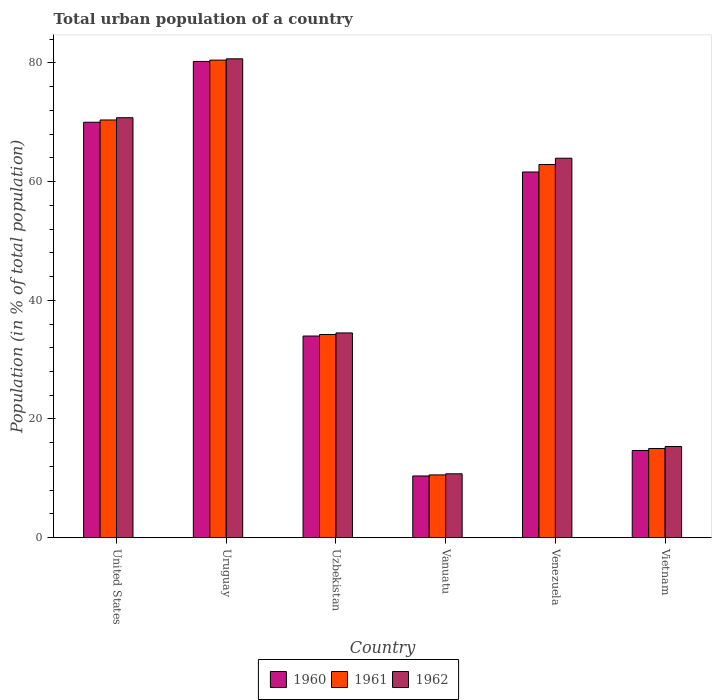How many bars are there on the 2nd tick from the left?
Give a very brief answer. 3. How many bars are there on the 2nd tick from the right?
Keep it short and to the point. 3. In how many cases, is the number of bars for a given country not equal to the number of legend labels?
Offer a very short reply. 0. What is the urban population in 1962 in United States?
Provide a short and direct response. 70.76. Across all countries, what is the maximum urban population in 1961?
Provide a succinct answer. 80.46. Across all countries, what is the minimum urban population in 1960?
Ensure brevity in your answer.  10.4. In which country was the urban population in 1962 maximum?
Your answer should be compact. Uruguay. In which country was the urban population in 1961 minimum?
Provide a succinct answer. Vanuatu. What is the total urban population in 1961 in the graph?
Your response must be concise. 273.57. What is the difference between the urban population in 1962 in United States and that in Venezuela?
Make the answer very short. 6.82. What is the difference between the urban population in 1960 in Vanuatu and the urban population in 1961 in Venezuela?
Provide a succinct answer. -52.47. What is the average urban population in 1960 per country?
Provide a short and direct response. 45.16. What is the difference between the urban population of/in 1960 and urban population of/in 1961 in Venezuela?
Your response must be concise. -1.26. In how many countries, is the urban population in 1961 greater than 36 %?
Ensure brevity in your answer.  3. What is the ratio of the urban population in 1961 in Vanuatu to that in Venezuela?
Your answer should be very brief. 0.17. Is the urban population in 1962 in United States less than that in Uzbekistan?
Ensure brevity in your answer.  No. Is the difference between the urban population in 1960 in Uzbekistan and Vanuatu greater than the difference between the urban population in 1961 in Uzbekistan and Vanuatu?
Offer a very short reply. No. What is the difference between the highest and the second highest urban population in 1961?
Keep it short and to the point. 17.59. What is the difference between the highest and the lowest urban population in 1962?
Your answer should be compact. 69.92. What does the 1st bar from the left in Venezuela represents?
Offer a very short reply. 1960. What does the 2nd bar from the right in Uruguay represents?
Offer a very short reply. 1961. Are the values on the major ticks of Y-axis written in scientific E-notation?
Provide a succinct answer. No. Does the graph contain any zero values?
Make the answer very short. No. How are the legend labels stacked?
Provide a short and direct response. Horizontal. What is the title of the graph?
Your answer should be compact. Total urban population of a country. What is the label or title of the Y-axis?
Your answer should be very brief. Population (in % of total population). What is the Population (in % of total population) in 1960 in United States?
Offer a terse response. 70. What is the Population (in % of total population) in 1961 in United States?
Offer a terse response. 70.38. What is the Population (in % of total population) of 1962 in United States?
Provide a succinct answer. 70.76. What is the Population (in % of total population) in 1960 in Uruguay?
Offer a very short reply. 80.24. What is the Population (in % of total population) in 1961 in Uruguay?
Provide a succinct answer. 80.46. What is the Population (in % of total population) of 1962 in Uruguay?
Your answer should be compact. 80.68. What is the Population (in % of total population) in 1960 in Uzbekistan?
Offer a terse response. 33.98. What is the Population (in % of total population) in 1961 in Uzbekistan?
Your answer should be compact. 34.24. What is the Population (in % of total population) of 1962 in Uzbekistan?
Give a very brief answer. 34.5. What is the Population (in % of total population) of 1960 in Vanuatu?
Ensure brevity in your answer.  10.4. What is the Population (in % of total population) in 1961 in Vanuatu?
Keep it short and to the point. 10.58. What is the Population (in % of total population) of 1962 in Vanuatu?
Keep it short and to the point. 10.77. What is the Population (in % of total population) of 1960 in Venezuela?
Your answer should be compact. 61.61. What is the Population (in % of total population) of 1961 in Venezuela?
Offer a terse response. 62.88. What is the Population (in % of total population) in 1962 in Venezuela?
Provide a succinct answer. 63.93. What is the Population (in % of total population) of 1960 in Vietnam?
Give a very brief answer. 14.7. What is the Population (in % of total population) of 1961 in Vietnam?
Keep it short and to the point. 15.03. What is the Population (in % of total population) in 1962 in Vietnam?
Your answer should be compact. 15.37. Across all countries, what is the maximum Population (in % of total population) of 1960?
Ensure brevity in your answer.  80.24. Across all countries, what is the maximum Population (in % of total population) in 1961?
Ensure brevity in your answer.  80.46. Across all countries, what is the maximum Population (in % of total population) in 1962?
Your answer should be compact. 80.68. Across all countries, what is the minimum Population (in % of total population) in 1960?
Provide a succinct answer. 10.4. Across all countries, what is the minimum Population (in % of total population) of 1961?
Keep it short and to the point. 10.58. Across all countries, what is the minimum Population (in % of total population) in 1962?
Offer a terse response. 10.77. What is the total Population (in % of total population) in 1960 in the graph?
Your answer should be compact. 270.93. What is the total Population (in % of total population) in 1961 in the graph?
Provide a succinct answer. 273.57. What is the total Population (in % of total population) of 1962 in the graph?
Give a very brief answer. 276. What is the difference between the Population (in % of total population) of 1960 in United States and that in Uruguay?
Provide a short and direct response. -10.24. What is the difference between the Population (in % of total population) of 1961 in United States and that in Uruguay?
Keep it short and to the point. -10.09. What is the difference between the Population (in % of total population) in 1962 in United States and that in Uruguay?
Ensure brevity in your answer.  -9.92. What is the difference between the Population (in % of total population) in 1960 in United States and that in Uzbekistan?
Make the answer very short. 36.02. What is the difference between the Population (in % of total population) in 1961 in United States and that in Uzbekistan?
Your answer should be very brief. 36.14. What is the difference between the Population (in % of total population) of 1962 in United States and that in Uzbekistan?
Offer a very short reply. 36.26. What is the difference between the Population (in % of total population) of 1960 in United States and that in Vanuatu?
Make the answer very short. 59.59. What is the difference between the Population (in % of total population) in 1961 in United States and that in Vanuatu?
Offer a terse response. 59.79. What is the difference between the Population (in % of total population) in 1962 in United States and that in Vanuatu?
Ensure brevity in your answer.  59.99. What is the difference between the Population (in % of total population) of 1960 in United States and that in Venezuela?
Provide a succinct answer. 8.38. What is the difference between the Population (in % of total population) in 1961 in United States and that in Venezuela?
Make the answer very short. 7.5. What is the difference between the Population (in % of total population) of 1962 in United States and that in Venezuela?
Your response must be concise. 6.82. What is the difference between the Population (in % of total population) in 1960 in United States and that in Vietnam?
Your answer should be compact. 55.3. What is the difference between the Population (in % of total population) of 1961 in United States and that in Vietnam?
Make the answer very short. 55.35. What is the difference between the Population (in % of total population) in 1962 in United States and that in Vietnam?
Make the answer very short. 55.39. What is the difference between the Population (in % of total population) of 1960 in Uruguay and that in Uzbekistan?
Offer a very short reply. 46.26. What is the difference between the Population (in % of total population) in 1961 in Uruguay and that in Uzbekistan?
Your response must be concise. 46.22. What is the difference between the Population (in % of total population) of 1962 in Uruguay and that in Uzbekistan?
Make the answer very short. 46.18. What is the difference between the Population (in % of total population) of 1960 in Uruguay and that in Vanuatu?
Provide a short and direct response. 69.84. What is the difference between the Population (in % of total population) in 1961 in Uruguay and that in Vanuatu?
Offer a terse response. 69.88. What is the difference between the Population (in % of total population) of 1962 in Uruguay and that in Vanuatu?
Make the answer very short. 69.92. What is the difference between the Population (in % of total population) in 1960 in Uruguay and that in Venezuela?
Your answer should be very brief. 18.63. What is the difference between the Population (in % of total population) of 1961 in Uruguay and that in Venezuela?
Offer a terse response. 17.59. What is the difference between the Population (in % of total population) of 1962 in Uruguay and that in Venezuela?
Provide a succinct answer. 16.75. What is the difference between the Population (in % of total population) of 1960 in Uruguay and that in Vietnam?
Your response must be concise. 65.54. What is the difference between the Population (in % of total population) in 1961 in Uruguay and that in Vietnam?
Ensure brevity in your answer.  65.43. What is the difference between the Population (in % of total population) of 1962 in Uruguay and that in Vietnam?
Your answer should be very brief. 65.31. What is the difference between the Population (in % of total population) in 1960 in Uzbekistan and that in Vanuatu?
Offer a very short reply. 23.57. What is the difference between the Population (in % of total population) in 1961 in Uzbekistan and that in Vanuatu?
Your answer should be very brief. 23.66. What is the difference between the Population (in % of total population) of 1962 in Uzbekistan and that in Vanuatu?
Ensure brevity in your answer.  23.73. What is the difference between the Population (in % of total population) of 1960 in Uzbekistan and that in Venezuela?
Your response must be concise. -27.64. What is the difference between the Population (in % of total population) in 1961 in Uzbekistan and that in Venezuela?
Offer a very short reply. -28.64. What is the difference between the Population (in % of total population) of 1962 in Uzbekistan and that in Venezuela?
Your answer should be compact. -29.43. What is the difference between the Population (in % of total population) in 1960 in Uzbekistan and that in Vietnam?
Offer a terse response. 19.28. What is the difference between the Population (in % of total population) of 1961 in Uzbekistan and that in Vietnam?
Provide a short and direct response. 19.21. What is the difference between the Population (in % of total population) in 1962 in Uzbekistan and that in Vietnam?
Give a very brief answer. 19.13. What is the difference between the Population (in % of total population) in 1960 in Vanuatu and that in Venezuela?
Provide a succinct answer. -51.21. What is the difference between the Population (in % of total population) of 1961 in Vanuatu and that in Venezuela?
Provide a succinct answer. -52.29. What is the difference between the Population (in % of total population) in 1962 in Vanuatu and that in Venezuela?
Offer a terse response. -53.17. What is the difference between the Population (in % of total population) in 1960 in Vanuatu and that in Vietnam?
Your answer should be very brief. -4.3. What is the difference between the Population (in % of total population) of 1961 in Vanuatu and that in Vietnam?
Your answer should be compact. -4.45. What is the difference between the Population (in % of total population) in 1962 in Vanuatu and that in Vietnam?
Your answer should be very brief. -4.6. What is the difference between the Population (in % of total population) in 1960 in Venezuela and that in Vietnam?
Offer a very short reply. 46.91. What is the difference between the Population (in % of total population) in 1961 in Venezuela and that in Vietnam?
Your answer should be compact. 47.84. What is the difference between the Population (in % of total population) in 1962 in Venezuela and that in Vietnam?
Offer a very short reply. 48.56. What is the difference between the Population (in % of total population) in 1960 in United States and the Population (in % of total population) in 1961 in Uruguay?
Your answer should be very brief. -10.47. What is the difference between the Population (in % of total population) in 1960 in United States and the Population (in % of total population) in 1962 in Uruguay?
Make the answer very short. -10.69. What is the difference between the Population (in % of total population) of 1961 in United States and the Population (in % of total population) of 1962 in Uruguay?
Offer a terse response. -10.3. What is the difference between the Population (in % of total population) of 1960 in United States and the Population (in % of total population) of 1961 in Uzbekistan?
Provide a succinct answer. 35.76. What is the difference between the Population (in % of total population) in 1960 in United States and the Population (in % of total population) in 1962 in Uzbekistan?
Your response must be concise. 35.5. What is the difference between the Population (in % of total population) of 1961 in United States and the Population (in % of total population) of 1962 in Uzbekistan?
Make the answer very short. 35.88. What is the difference between the Population (in % of total population) in 1960 in United States and the Population (in % of total population) in 1961 in Vanuatu?
Your answer should be compact. 59.41. What is the difference between the Population (in % of total population) in 1960 in United States and the Population (in % of total population) in 1962 in Vanuatu?
Offer a very short reply. 59.23. What is the difference between the Population (in % of total population) of 1961 in United States and the Population (in % of total population) of 1962 in Vanuatu?
Make the answer very short. 59.61. What is the difference between the Population (in % of total population) in 1960 in United States and the Population (in % of total population) in 1961 in Venezuela?
Your response must be concise. 7.12. What is the difference between the Population (in % of total population) of 1960 in United States and the Population (in % of total population) of 1962 in Venezuela?
Provide a succinct answer. 6.06. What is the difference between the Population (in % of total population) in 1961 in United States and the Population (in % of total population) in 1962 in Venezuela?
Your answer should be compact. 6.44. What is the difference between the Population (in % of total population) in 1960 in United States and the Population (in % of total population) in 1961 in Vietnam?
Keep it short and to the point. 54.97. What is the difference between the Population (in % of total population) of 1960 in United States and the Population (in % of total population) of 1962 in Vietnam?
Your answer should be compact. 54.63. What is the difference between the Population (in % of total population) of 1961 in United States and the Population (in % of total population) of 1962 in Vietnam?
Provide a succinct answer. 55.01. What is the difference between the Population (in % of total population) of 1960 in Uruguay and the Population (in % of total population) of 1961 in Uzbekistan?
Offer a terse response. 46. What is the difference between the Population (in % of total population) of 1960 in Uruguay and the Population (in % of total population) of 1962 in Uzbekistan?
Your answer should be compact. 45.74. What is the difference between the Population (in % of total population) of 1961 in Uruguay and the Population (in % of total population) of 1962 in Uzbekistan?
Your answer should be compact. 45.96. What is the difference between the Population (in % of total population) in 1960 in Uruguay and the Population (in % of total population) in 1961 in Vanuatu?
Ensure brevity in your answer.  69.66. What is the difference between the Population (in % of total population) of 1960 in Uruguay and the Population (in % of total population) of 1962 in Vanuatu?
Offer a terse response. 69.48. What is the difference between the Population (in % of total population) in 1961 in Uruguay and the Population (in % of total population) in 1962 in Vanuatu?
Provide a short and direct response. 69.7. What is the difference between the Population (in % of total population) in 1960 in Uruguay and the Population (in % of total population) in 1961 in Venezuela?
Your answer should be compact. 17.37. What is the difference between the Population (in % of total population) of 1960 in Uruguay and the Population (in % of total population) of 1962 in Venezuela?
Offer a very short reply. 16.31. What is the difference between the Population (in % of total population) in 1961 in Uruguay and the Population (in % of total population) in 1962 in Venezuela?
Your answer should be compact. 16.53. What is the difference between the Population (in % of total population) in 1960 in Uruguay and the Population (in % of total population) in 1961 in Vietnam?
Make the answer very short. 65.21. What is the difference between the Population (in % of total population) of 1960 in Uruguay and the Population (in % of total population) of 1962 in Vietnam?
Provide a succinct answer. 64.87. What is the difference between the Population (in % of total population) in 1961 in Uruguay and the Population (in % of total population) in 1962 in Vietnam?
Offer a terse response. 65.09. What is the difference between the Population (in % of total population) of 1960 in Uzbekistan and the Population (in % of total population) of 1961 in Vanuatu?
Your response must be concise. 23.39. What is the difference between the Population (in % of total population) of 1960 in Uzbekistan and the Population (in % of total population) of 1962 in Vanuatu?
Provide a short and direct response. 23.21. What is the difference between the Population (in % of total population) of 1961 in Uzbekistan and the Population (in % of total population) of 1962 in Vanuatu?
Ensure brevity in your answer.  23.47. What is the difference between the Population (in % of total population) in 1960 in Uzbekistan and the Population (in % of total population) in 1961 in Venezuela?
Offer a very short reply. -28.9. What is the difference between the Population (in % of total population) in 1960 in Uzbekistan and the Population (in % of total population) in 1962 in Venezuela?
Provide a short and direct response. -29.95. What is the difference between the Population (in % of total population) in 1961 in Uzbekistan and the Population (in % of total population) in 1962 in Venezuela?
Your answer should be compact. -29.7. What is the difference between the Population (in % of total population) in 1960 in Uzbekistan and the Population (in % of total population) in 1961 in Vietnam?
Your response must be concise. 18.95. What is the difference between the Population (in % of total population) of 1960 in Uzbekistan and the Population (in % of total population) of 1962 in Vietnam?
Give a very brief answer. 18.61. What is the difference between the Population (in % of total population) in 1961 in Uzbekistan and the Population (in % of total population) in 1962 in Vietnam?
Make the answer very short. 18.87. What is the difference between the Population (in % of total population) of 1960 in Vanuatu and the Population (in % of total population) of 1961 in Venezuela?
Keep it short and to the point. -52.47. What is the difference between the Population (in % of total population) of 1960 in Vanuatu and the Population (in % of total population) of 1962 in Venezuela?
Make the answer very short. -53.53. What is the difference between the Population (in % of total population) of 1961 in Vanuatu and the Population (in % of total population) of 1962 in Venezuela?
Keep it short and to the point. -53.35. What is the difference between the Population (in % of total population) of 1960 in Vanuatu and the Population (in % of total population) of 1961 in Vietnam?
Your answer should be compact. -4.63. What is the difference between the Population (in % of total population) of 1960 in Vanuatu and the Population (in % of total population) of 1962 in Vietnam?
Your response must be concise. -4.96. What is the difference between the Population (in % of total population) in 1961 in Vanuatu and the Population (in % of total population) in 1962 in Vietnam?
Offer a terse response. -4.79. What is the difference between the Population (in % of total population) in 1960 in Venezuela and the Population (in % of total population) in 1961 in Vietnam?
Give a very brief answer. 46.58. What is the difference between the Population (in % of total population) in 1960 in Venezuela and the Population (in % of total population) in 1962 in Vietnam?
Offer a terse response. 46.24. What is the difference between the Population (in % of total population) in 1961 in Venezuela and the Population (in % of total population) in 1962 in Vietnam?
Your answer should be compact. 47.51. What is the average Population (in % of total population) in 1960 per country?
Keep it short and to the point. 45.16. What is the average Population (in % of total population) of 1961 per country?
Give a very brief answer. 45.59. What is the average Population (in % of total population) in 1962 per country?
Your answer should be compact. 46. What is the difference between the Population (in % of total population) of 1960 and Population (in % of total population) of 1961 in United States?
Your response must be concise. -0.38. What is the difference between the Population (in % of total population) of 1960 and Population (in % of total population) of 1962 in United States?
Provide a short and direct response. -0.76. What is the difference between the Population (in % of total population) of 1961 and Population (in % of total population) of 1962 in United States?
Give a very brief answer. -0.38. What is the difference between the Population (in % of total population) of 1960 and Population (in % of total population) of 1961 in Uruguay?
Offer a terse response. -0.22. What is the difference between the Population (in % of total population) of 1960 and Population (in % of total population) of 1962 in Uruguay?
Offer a terse response. -0.44. What is the difference between the Population (in % of total population) of 1961 and Population (in % of total population) of 1962 in Uruguay?
Your answer should be very brief. -0.22. What is the difference between the Population (in % of total population) of 1960 and Population (in % of total population) of 1961 in Uzbekistan?
Keep it short and to the point. -0.26. What is the difference between the Population (in % of total population) of 1960 and Population (in % of total population) of 1962 in Uzbekistan?
Provide a succinct answer. -0.52. What is the difference between the Population (in % of total population) of 1961 and Population (in % of total population) of 1962 in Uzbekistan?
Ensure brevity in your answer.  -0.26. What is the difference between the Population (in % of total population) in 1960 and Population (in % of total population) in 1961 in Vanuatu?
Ensure brevity in your answer.  -0.18. What is the difference between the Population (in % of total population) of 1960 and Population (in % of total population) of 1962 in Vanuatu?
Give a very brief answer. -0.36. What is the difference between the Population (in % of total population) in 1961 and Population (in % of total population) in 1962 in Vanuatu?
Make the answer very short. -0.18. What is the difference between the Population (in % of total population) in 1960 and Population (in % of total population) in 1961 in Venezuela?
Provide a succinct answer. -1.26. What is the difference between the Population (in % of total population) of 1960 and Population (in % of total population) of 1962 in Venezuela?
Ensure brevity in your answer.  -2.32. What is the difference between the Population (in % of total population) of 1961 and Population (in % of total population) of 1962 in Venezuela?
Ensure brevity in your answer.  -1.06. What is the difference between the Population (in % of total population) of 1960 and Population (in % of total population) of 1961 in Vietnam?
Make the answer very short. -0.33. What is the difference between the Population (in % of total population) of 1960 and Population (in % of total population) of 1962 in Vietnam?
Your response must be concise. -0.67. What is the difference between the Population (in % of total population) in 1961 and Population (in % of total population) in 1962 in Vietnam?
Provide a succinct answer. -0.34. What is the ratio of the Population (in % of total population) in 1960 in United States to that in Uruguay?
Your answer should be compact. 0.87. What is the ratio of the Population (in % of total population) in 1961 in United States to that in Uruguay?
Your answer should be compact. 0.87. What is the ratio of the Population (in % of total population) of 1962 in United States to that in Uruguay?
Provide a succinct answer. 0.88. What is the ratio of the Population (in % of total population) in 1960 in United States to that in Uzbekistan?
Give a very brief answer. 2.06. What is the ratio of the Population (in % of total population) of 1961 in United States to that in Uzbekistan?
Provide a short and direct response. 2.06. What is the ratio of the Population (in % of total population) in 1962 in United States to that in Uzbekistan?
Give a very brief answer. 2.05. What is the ratio of the Population (in % of total population) in 1960 in United States to that in Vanuatu?
Provide a short and direct response. 6.73. What is the ratio of the Population (in % of total population) of 1961 in United States to that in Vanuatu?
Provide a short and direct response. 6.65. What is the ratio of the Population (in % of total population) in 1962 in United States to that in Vanuatu?
Your response must be concise. 6.57. What is the ratio of the Population (in % of total population) of 1960 in United States to that in Venezuela?
Give a very brief answer. 1.14. What is the ratio of the Population (in % of total population) in 1961 in United States to that in Venezuela?
Make the answer very short. 1.12. What is the ratio of the Population (in % of total population) of 1962 in United States to that in Venezuela?
Give a very brief answer. 1.11. What is the ratio of the Population (in % of total population) in 1960 in United States to that in Vietnam?
Offer a terse response. 4.76. What is the ratio of the Population (in % of total population) of 1961 in United States to that in Vietnam?
Offer a very short reply. 4.68. What is the ratio of the Population (in % of total population) of 1962 in United States to that in Vietnam?
Provide a succinct answer. 4.6. What is the ratio of the Population (in % of total population) in 1960 in Uruguay to that in Uzbekistan?
Ensure brevity in your answer.  2.36. What is the ratio of the Population (in % of total population) in 1961 in Uruguay to that in Uzbekistan?
Your response must be concise. 2.35. What is the ratio of the Population (in % of total population) in 1962 in Uruguay to that in Uzbekistan?
Offer a very short reply. 2.34. What is the ratio of the Population (in % of total population) of 1960 in Uruguay to that in Vanuatu?
Make the answer very short. 7.71. What is the ratio of the Population (in % of total population) in 1961 in Uruguay to that in Vanuatu?
Give a very brief answer. 7.6. What is the ratio of the Population (in % of total population) of 1962 in Uruguay to that in Vanuatu?
Your answer should be compact. 7.49. What is the ratio of the Population (in % of total population) of 1960 in Uruguay to that in Venezuela?
Offer a terse response. 1.3. What is the ratio of the Population (in % of total population) of 1961 in Uruguay to that in Venezuela?
Give a very brief answer. 1.28. What is the ratio of the Population (in % of total population) in 1962 in Uruguay to that in Venezuela?
Offer a terse response. 1.26. What is the ratio of the Population (in % of total population) in 1960 in Uruguay to that in Vietnam?
Give a very brief answer. 5.46. What is the ratio of the Population (in % of total population) of 1961 in Uruguay to that in Vietnam?
Your response must be concise. 5.35. What is the ratio of the Population (in % of total population) of 1962 in Uruguay to that in Vietnam?
Provide a short and direct response. 5.25. What is the ratio of the Population (in % of total population) in 1960 in Uzbekistan to that in Vanuatu?
Your answer should be very brief. 3.27. What is the ratio of the Population (in % of total population) of 1961 in Uzbekistan to that in Vanuatu?
Your answer should be compact. 3.24. What is the ratio of the Population (in % of total population) in 1962 in Uzbekistan to that in Vanuatu?
Offer a very short reply. 3.2. What is the ratio of the Population (in % of total population) of 1960 in Uzbekistan to that in Venezuela?
Your answer should be very brief. 0.55. What is the ratio of the Population (in % of total population) of 1961 in Uzbekistan to that in Venezuela?
Keep it short and to the point. 0.54. What is the ratio of the Population (in % of total population) in 1962 in Uzbekistan to that in Venezuela?
Your answer should be compact. 0.54. What is the ratio of the Population (in % of total population) of 1960 in Uzbekistan to that in Vietnam?
Your answer should be very brief. 2.31. What is the ratio of the Population (in % of total population) in 1961 in Uzbekistan to that in Vietnam?
Make the answer very short. 2.28. What is the ratio of the Population (in % of total population) in 1962 in Uzbekistan to that in Vietnam?
Offer a terse response. 2.24. What is the ratio of the Population (in % of total population) in 1960 in Vanuatu to that in Venezuela?
Your answer should be compact. 0.17. What is the ratio of the Population (in % of total population) in 1961 in Vanuatu to that in Venezuela?
Your answer should be compact. 0.17. What is the ratio of the Population (in % of total population) of 1962 in Vanuatu to that in Venezuela?
Make the answer very short. 0.17. What is the ratio of the Population (in % of total population) in 1960 in Vanuatu to that in Vietnam?
Your answer should be very brief. 0.71. What is the ratio of the Population (in % of total population) of 1961 in Vanuatu to that in Vietnam?
Provide a succinct answer. 0.7. What is the ratio of the Population (in % of total population) in 1962 in Vanuatu to that in Vietnam?
Your response must be concise. 0.7. What is the ratio of the Population (in % of total population) in 1960 in Venezuela to that in Vietnam?
Provide a short and direct response. 4.19. What is the ratio of the Population (in % of total population) of 1961 in Venezuela to that in Vietnam?
Your response must be concise. 4.18. What is the ratio of the Population (in % of total population) of 1962 in Venezuela to that in Vietnam?
Make the answer very short. 4.16. What is the difference between the highest and the second highest Population (in % of total population) in 1960?
Keep it short and to the point. 10.24. What is the difference between the highest and the second highest Population (in % of total population) in 1961?
Keep it short and to the point. 10.09. What is the difference between the highest and the second highest Population (in % of total population) in 1962?
Provide a succinct answer. 9.92. What is the difference between the highest and the lowest Population (in % of total population) of 1960?
Give a very brief answer. 69.84. What is the difference between the highest and the lowest Population (in % of total population) of 1961?
Provide a short and direct response. 69.88. What is the difference between the highest and the lowest Population (in % of total population) in 1962?
Offer a very short reply. 69.92. 